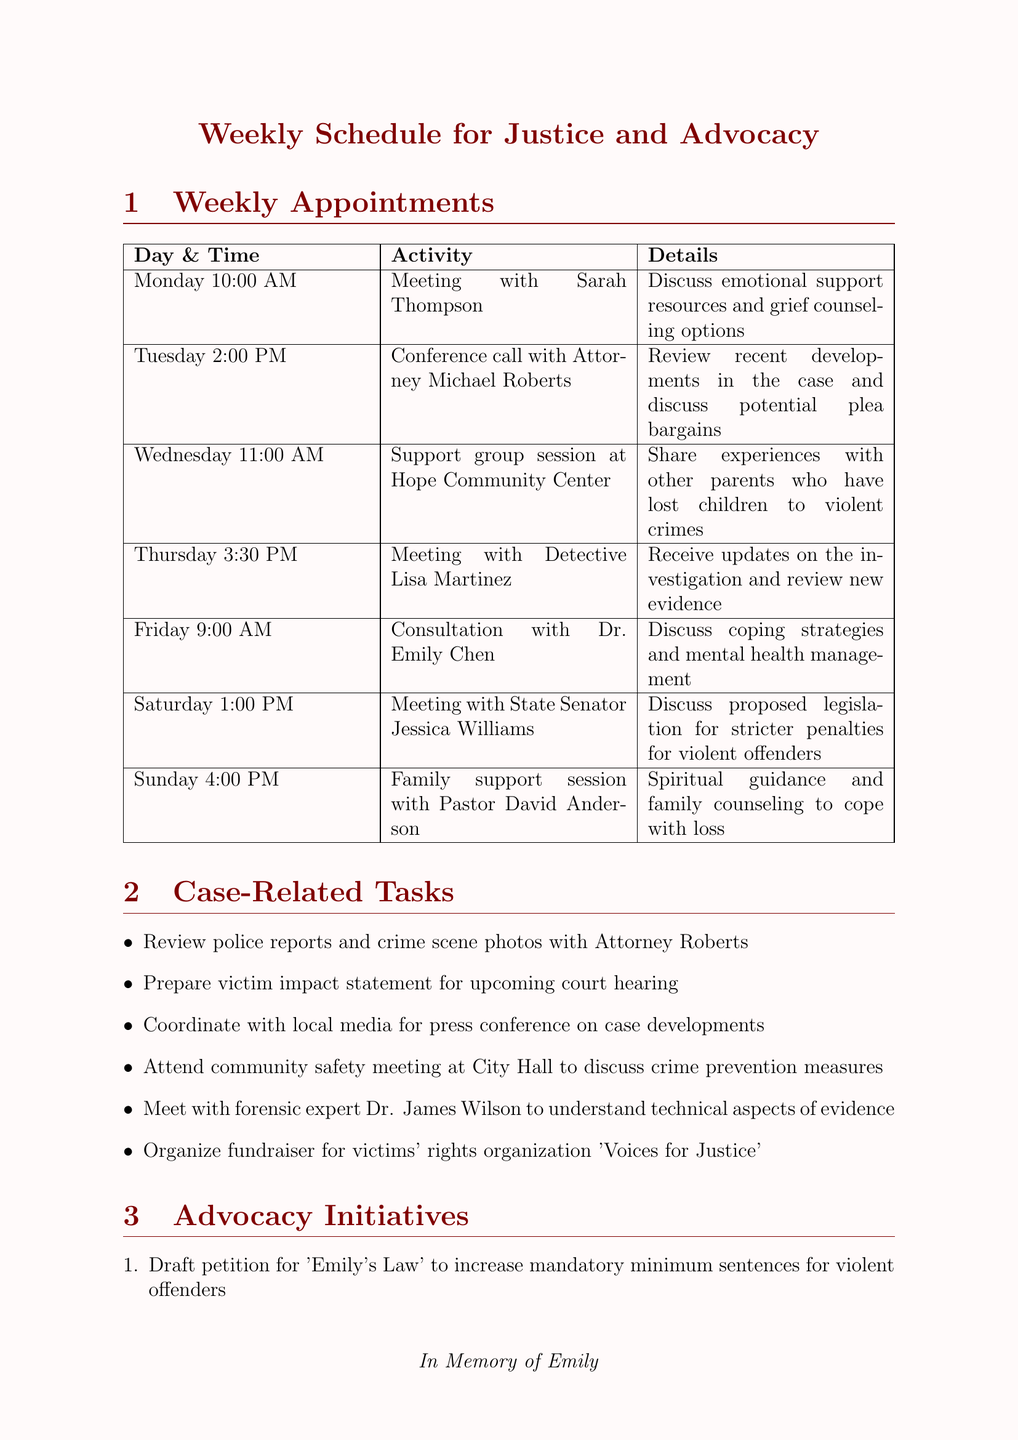What day is the meeting with Sarah Thompson? The meeting with Sarah Thompson is scheduled for Monday at 10:00 AM as stated in the weekly appointments.
Answer: Monday What time is the consultation with Dr. Emily Chen? The consultation with Dr. Emily Chen takes place on Friday at 9:00 AM according to the schedule.
Answer: 9:00 AM Who will be met on Saturday? The meeting scheduled for Saturday is with State Senator Jessica Williams as mentioned in the document.
Answer: State Senator Jessica Williams What activity is planned for Wednesday? On Wednesday, the activity planned is a support group session at Hope Community Center, as listed in the schedule.
Answer: Support group session at Hope Community Center How many case-related tasks are listed? The document lists a total of six case-related tasks in the relevant section.
Answer: 6 What is the focus of the advocacy initiative titled 'Emily's Law'? 'Emily's Law' aims to increase mandatory minimum sentences for violent offenders as mentioned in the advocacy initiatives.
Answer: Increase mandatory minimum sentences What is the time for the family support session on Sunday? The family support session on Sunday is scheduled for 4:00 PM as indicated in the weekly appointments section.
Answer: 4:00 PM Who provides spiritual guidance in the Sunday session? Pastor David Anderson provides spiritual guidance during the family support session as noted in the document.
Answer: Pastor David Anderson 